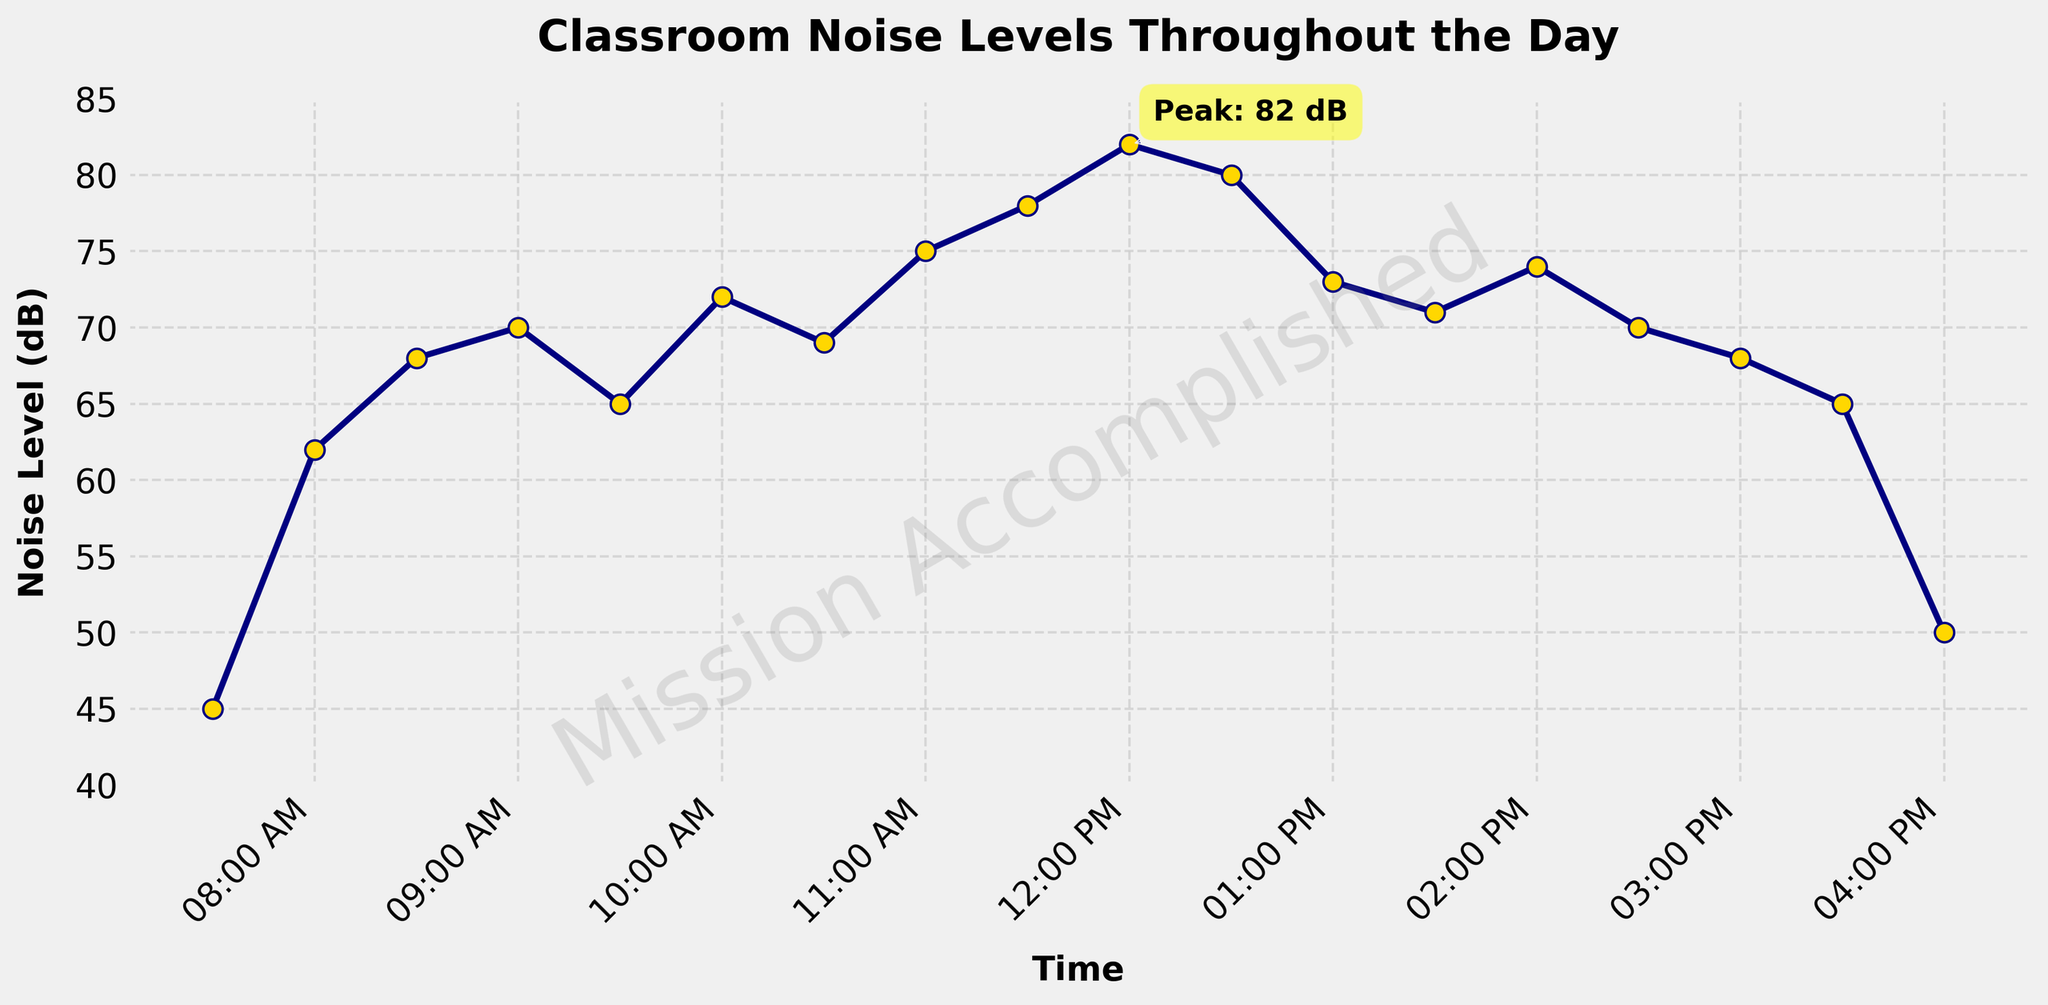What time does the noise level peak and what is the decibel level at that time? The peak noise level is annotated in the figure. The annotation shows the highest value and notes the time. This is at 12:00 PM with a noise level of 82 dB.
Answer: 12:00 PM, 82 dB What is the general trend of noise levels from 7:30 AM to 12:00 PM? Observing the line chart from 7:30 AM to 12:00 PM, the noise levels steadily increase from 45 dB to the peak of 82 dB at 12:00 PM.
Answer: Increasing What is the noise level at 1:00 PM and how does it compare to the noise level at 12:00 PM? The figure shows that at 1:00 PM, the noise level is 73 dB, which is lower than the 82 dB at 12:00 PM. This can be observed by comparing the height of the points at these times.
Answer: Lower During which time period does the noise level decrease the most sharply? The largest drop in the noise level can be seen between 12:30 PM and 1:00 PM, where the noise level drops from 80 dB to 73 dB.
Answer: 12:30 PM to 1:00 PM Is there a major dip in the noise level at any point in the day? If so, when? The major dip occurs at 4:00 PM where the noise level sharply decreases to 50 dB, which is significantly lower compared to the previous time points.
Answer: 4:00 PM What is the average noise level between 10:00 AM and 11:30 AM? To find the average, add the noise levels at 10:00 AM (72 dB), 10:30 AM (69 dB), 11:00 AM (75 dB), and 11:30 AM (78 dB), then divide by the number of data points. (72 + 69 + 75 + 78) / 4 = 73.5 dB.
Answer: 73.5 dB How does the noise level change after the peak at 12:00 PM till 4:00 PM? After the peak at 12:00 PM, the noise level decreases to 80 dB at 12:30 PM, then fluctuates between 73 dB and 74 dB until 2:00 PM, and continues to decrease gradually to 50 dB by 4:00 PM.
Answer: Decreases What is the difference in noise levels between 2:00 PM and 3:00 PM? At 2:00 PM, the noise level is 74 dB, and at 3:00 PM, it is 68 dB. The difference is calculated as 74 - 68 = 6 dB.
Answer: 6 dB 